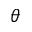Convert formula to latex. <formula><loc_0><loc_0><loc_500><loc_500>\theta</formula> 